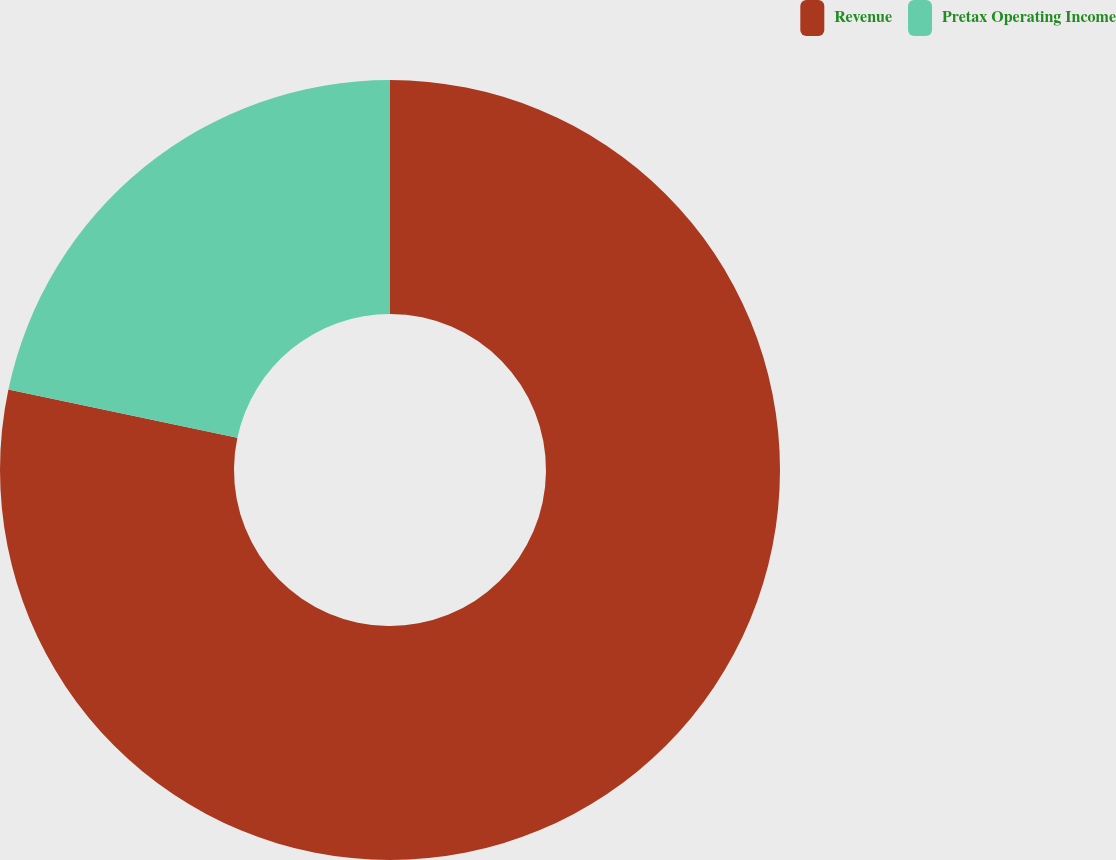<chart> <loc_0><loc_0><loc_500><loc_500><pie_chart><fcel>Revenue<fcel>Pretax Operating Income<nl><fcel>78.31%<fcel>21.69%<nl></chart> 